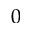<formula> <loc_0><loc_0><loc_500><loc_500>0</formula> 